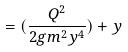<formula> <loc_0><loc_0><loc_500><loc_500>= ( \frac { Q ^ { 2 } } { 2 g m ^ { 2 } y ^ { 4 } } ) + y</formula> 